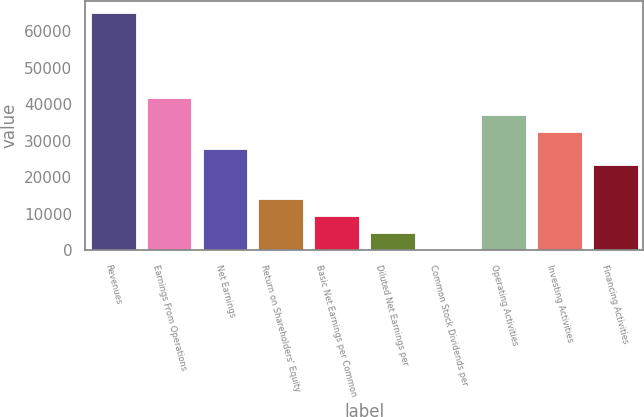Convert chart to OTSL. <chart><loc_0><loc_0><loc_500><loc_500><bar_chart><fcel>Revenues<fcel>Earnings From Operations<fcel>Net Earnings<fcel>Return on Shareholders' Equity<fcel>Basic Net Earnings per Common<fcel>Diluted Net Earnings per<fcel>Common Stock Dividends per<fcel>Operating Activities<fcel>Investing Activities<fcel>Financing Activities<nl><fcel>64995<fcel>41782.5<fcel>27855<fcel>13927.5<fcel>9285.01<fcel>4642.51<fcel>0.01<fcel>37140<fcel>32497.5<fcel>23212.5<nl></chart> 